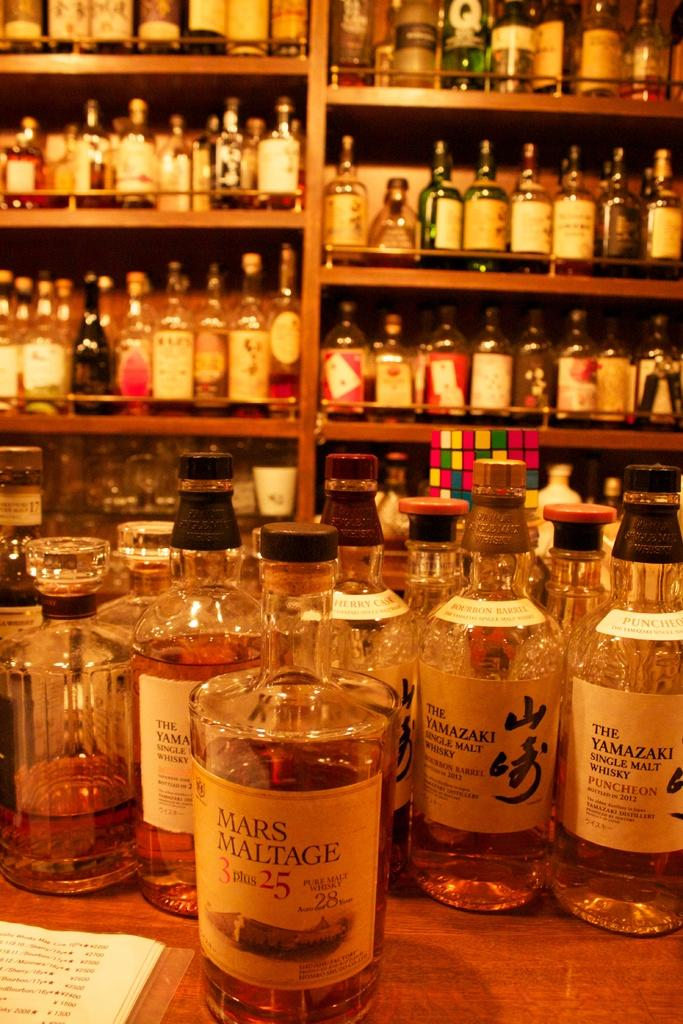<image>
Create a compact narrative representing the image presented. Several bottles of whiskey, one with "Mars Maltage" on the label. 